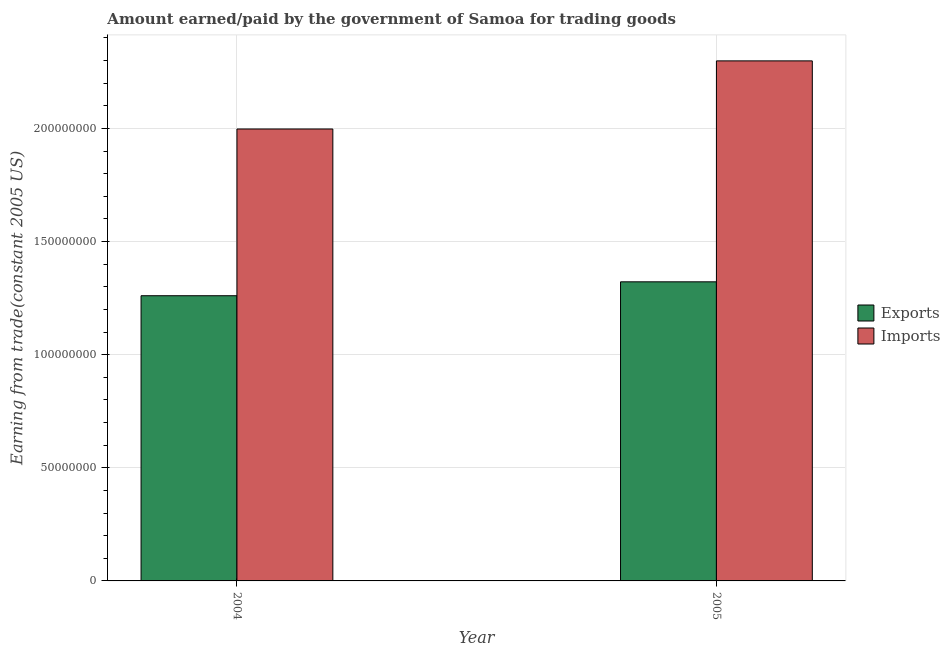How many different coloured bars are there?
Provide a succinct answer. 2. How many groups of bars are there?
Your answer should be compact. 2. Are the number of bars per tick equal to the number of legend labels?
Your answer should be compact. Yes. Are the number of bars on each tick of the X-axis equal?
Ensure brevity in your answer.  Yes. What is the amount paid for imports in 2005?
Give a very brief answer. 2.30e+08. Across all years, what is the maximum amount paid for imports?
Offer a terse response. 2.30e+08. Across all years, what is the minimum amount earned from exports?
Make the answer very short. 1.26e+08. What is the total amount paid for imports in the graph?
Make the answer very short. 4.30e+08. What is the difference between the amount paid for imports in 2004 and that in 2005?
Ensure brevity in your answer.  -3.01e+07. What is the difference between the amount earned from exports in 2005 and the amount paid for imports in 2004?
Provide a succinct answer. 6.15e+06. What is the average amount paid for imports per year?
Your answer should be compact. 2.15e+08. In the year 2005, what is the difference between the amount earned from exports and amount paid for imports?
Provide a succinct answer. 0. What is the ratio of the amount earned from exports in 2004 to that in 2005?
Make the answer very short. 0.95. Is the amount earned from exports in 2004 less than that in 2005?
Offer a very short reply. Yes. In how many years, is the amount paid for imports greater than the average amount paid for imports taken over all years?
Your answer should be compact. 1. What does the 2nd bar from the left in 2005 represents?
Your answer should be very brief. Imports. What does the 1st bar from the right in 2005 represents?
Your response must be concise. Imports. How many years are there in the graph?
Ensure brevity in your answer.  2. What is the difference between two consecutive major ticks on the Y-axis?
Your response must be concise. 5.00e+07. Does the graph contain any zero values?
Give a very brief answer. No. Where does the legend appear in the graph?
Your response must be concise. Center right. How many legend labels are there?
Make the answer very short. 2. How are the legend labels stacked?
Give a very brief answer. Vertical. What is the title of the graph?
Make the answer very short. Amount earned/paid by the government of Samoa for trading goods. What is the label or title of the Y-axis?
Your answer should be very brief. Earning from trade(constant 2005 US). What is the Earning from trade(constant 2005 US) in Exports in 2004?
Provide a succinct answer. 1.26e+08. What is the Earning from trade(constant 2005 US) in Imports in 2004?
Keep it short and to the point. 2.00e+08. What is the Earning from trade(constant 2005 US) of Exports in 2005?
Give a very brief answer. 1.32e+08. What is the Earning from trade(constant 2005 US) of Imports in 2005?
Your response must be concise. 2.30e+08. Across all years, what is the maximum Earning from trade(constant 2005 US) in Exports?
Offer a terse response. 1.32e+08. Across all years, what is the maximum Earning from trade(constant 2005 US) in Imports?
Provide a succinct answer. 2.30e+08. Across all years, what is the minimum Earning from trade(constant 2005 US) of Exports?
Keep it short and to the point. 1.26e+08. Across all years, what is the minimum Earning from trade(constant 2005 US) in Imports?
Your answer should be compact. 2.00e+08. What is the total Earning from trade(constant 2005 US) in Exports in the graph?
Ensure brevity in your answer.  2.58e+08. What is the total Earning from trade(constant 2005 US) in Imports in the graph?
Provide a short and direct response. 4.30e+08. What is the difference between the Earning from trade(constant 2005 US) in Exports in 2004 and that in 2005?
Offer a very short reply. -6.15e+06. What is the difference between the Earning from trade(constant 2005 US) of Imports in 2004 and that in 2005?
Make the answer very short. -3.01e+07. What is the difference between the Earning from trade(constant 2005 US) in Exports in 2004 and the Earning from trade(constant 2005 US) in Imports in 2005?
Your response must be concise. -1.04e+08. What is the average Earning from trade(constant 2005 US) in Exports per year?
Provide a short and direct response. 1.29e+08. What is the average Earning from trade(constant 2005 US) of Imports per year?
Keep it short and to the point. 2.15e+08. In the year 2004, what is the difference between the Earning from trade(constant 2005 US) of Exports and Earning from trade(constant 2005 US) of Imports?
Your answer should be very brief. -7.37e+07. In the year 2005, what is the difference between the Earning from trade(constant 2005 US) of Exports and Earning from trade(constant 2005 US) of Imports?
Offer a very short reply. -9.77e+07. What is the ratio of the Earning from trade(constant 2005 US) of Exports in 2004 to that in 2005?
Offer a very short reply. 0.95. What is the ratio of the Earning from trade(constant 2005 US) in Imports in 2004 to that in 2005?
Offer a terse response. 0.87. What is the difference between the highest and the second highest Earning from trade(constant 2005 US) in Exports?
Make the answer very short. 6.15e+06. What is the difference between the highest and the second highest Earning from trade(constant 2005 US) of Imports?
Provide a succinct answer. 3.01e+07. What is the difference between the highest and the lowest Earning from trade(constant 2005 US) of Exports?
Your answer should be very brief. 6.15e+06. What is the difference between the highest and the lowest Earning from trade(constant 2005 US) of Imports?
Offer a very short reply. 3.01e+07. 